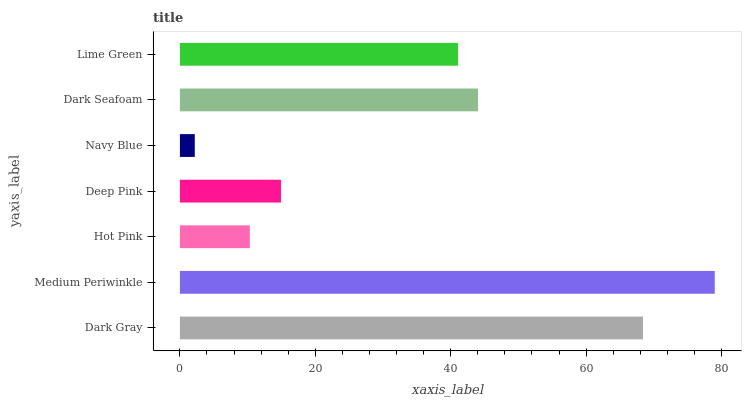Is Navy Blue the minimum?
Answer yes or no. Yes. Is Medium Periwinkle the maximum?
Answer yes or no. Yes. Is Hot Pink the minimum?
Answer yes or no. No. Is Hot Pink the maximum?
Answer yes or no. No. Is Medium Periwinkle greater than Hot Pink?
Answer yes or no. Yes. Is Hot Pink less than Medium Periwinkle?
Answer yes or no. Yes. Is Hot Pink greater than Medium Periwinkle?
Answer yes or no. No. Is Medium Periwinkle less than Hot Pink?
Answer yes or no. No. Is Lime Green the high median?
Answer yes or no. Yes. Is Lime Green the low median?
Answer yes or no. Yes. Is Medium Periwinkle the high median?
Answer yes or no. No. Is Medium Periwinkle the low median?
Answer yes or no. No. 